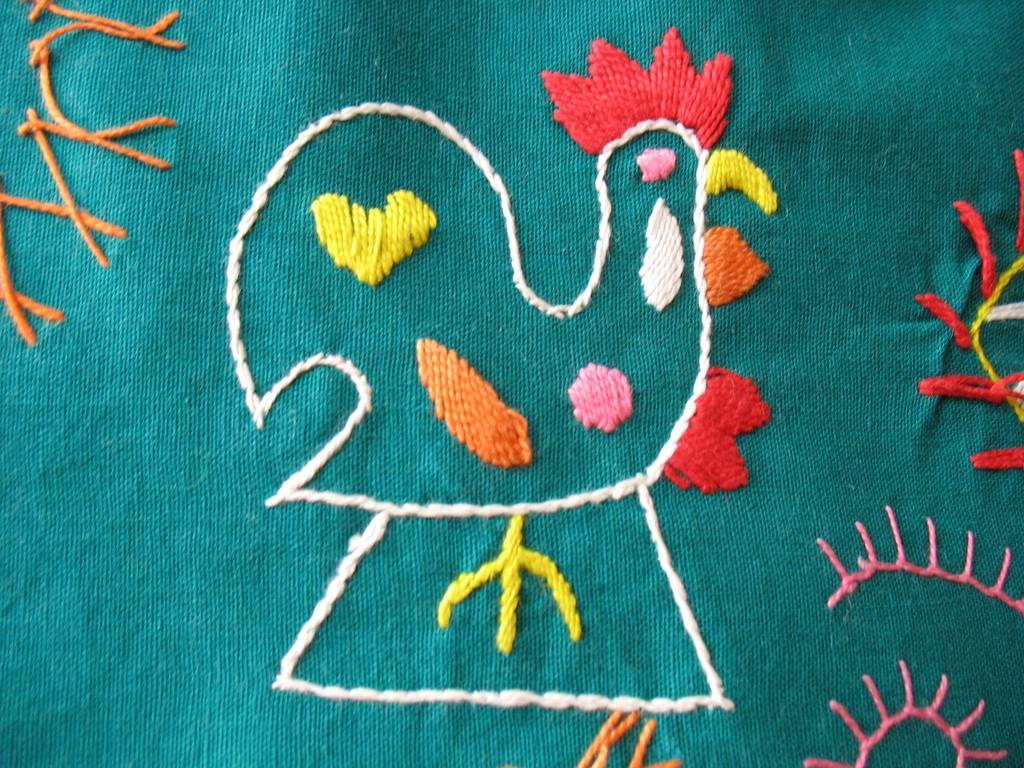Can you describe this image briefly? In this image we can see embroidery on cloth. 